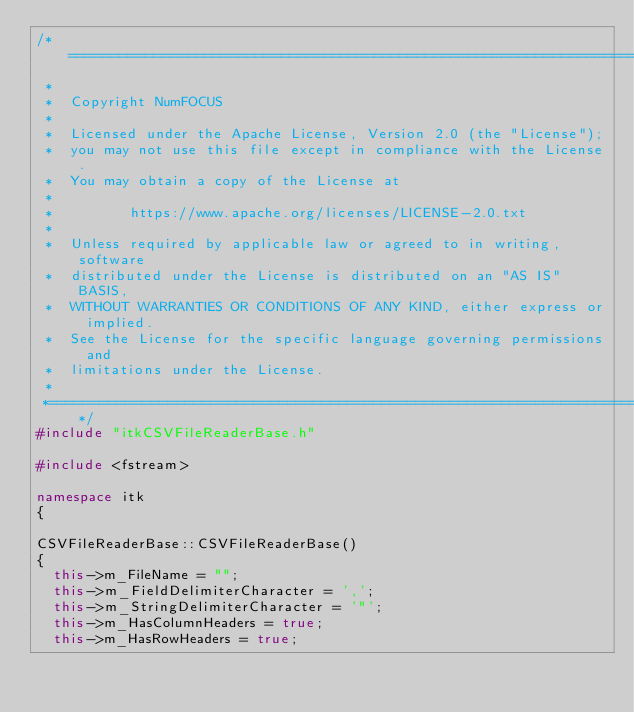<code> <loc_0><loc_0><loc_500><loc_500><_C++_>/*=========================================================================
 *
 *  Copyright NumFOCUS
 *
 *  Licensed under the Apache License, Version 2.0 (the "License");
 *  you may not use this file except in compliance with the License.
 *  You may obtain a copy of the License at
 *
 *         https://www.apache.org/licenses/LICENSE-2.0.txt
 *
 *  Unless required by applicable law or agreed to in writing, software
 *  distributed under the License is distributed on an "AS IS" BASIS,
 *  WITHOUT WARRANTIES OR CONDITIONS OF ANY KIND, either express or implied.
 *  See the License for the specific language governing permissions and
 *  limitations under the License.
 *
 *=========================================================================*/
#include "itkCSVFileReaderBase.h"

#include <fstream>

namespace itk
{

CSVFileReaderBase::CSVFileReaderBase()
{
  this->m_FileName = "";
  this->m_FieldDelimiterCharacter = ',';
  this->m_StringDelimiterCharacter = '"';
  this->m_HasColumnHeaders = true;
  this->m_HasRowHeaders = true;</code> 